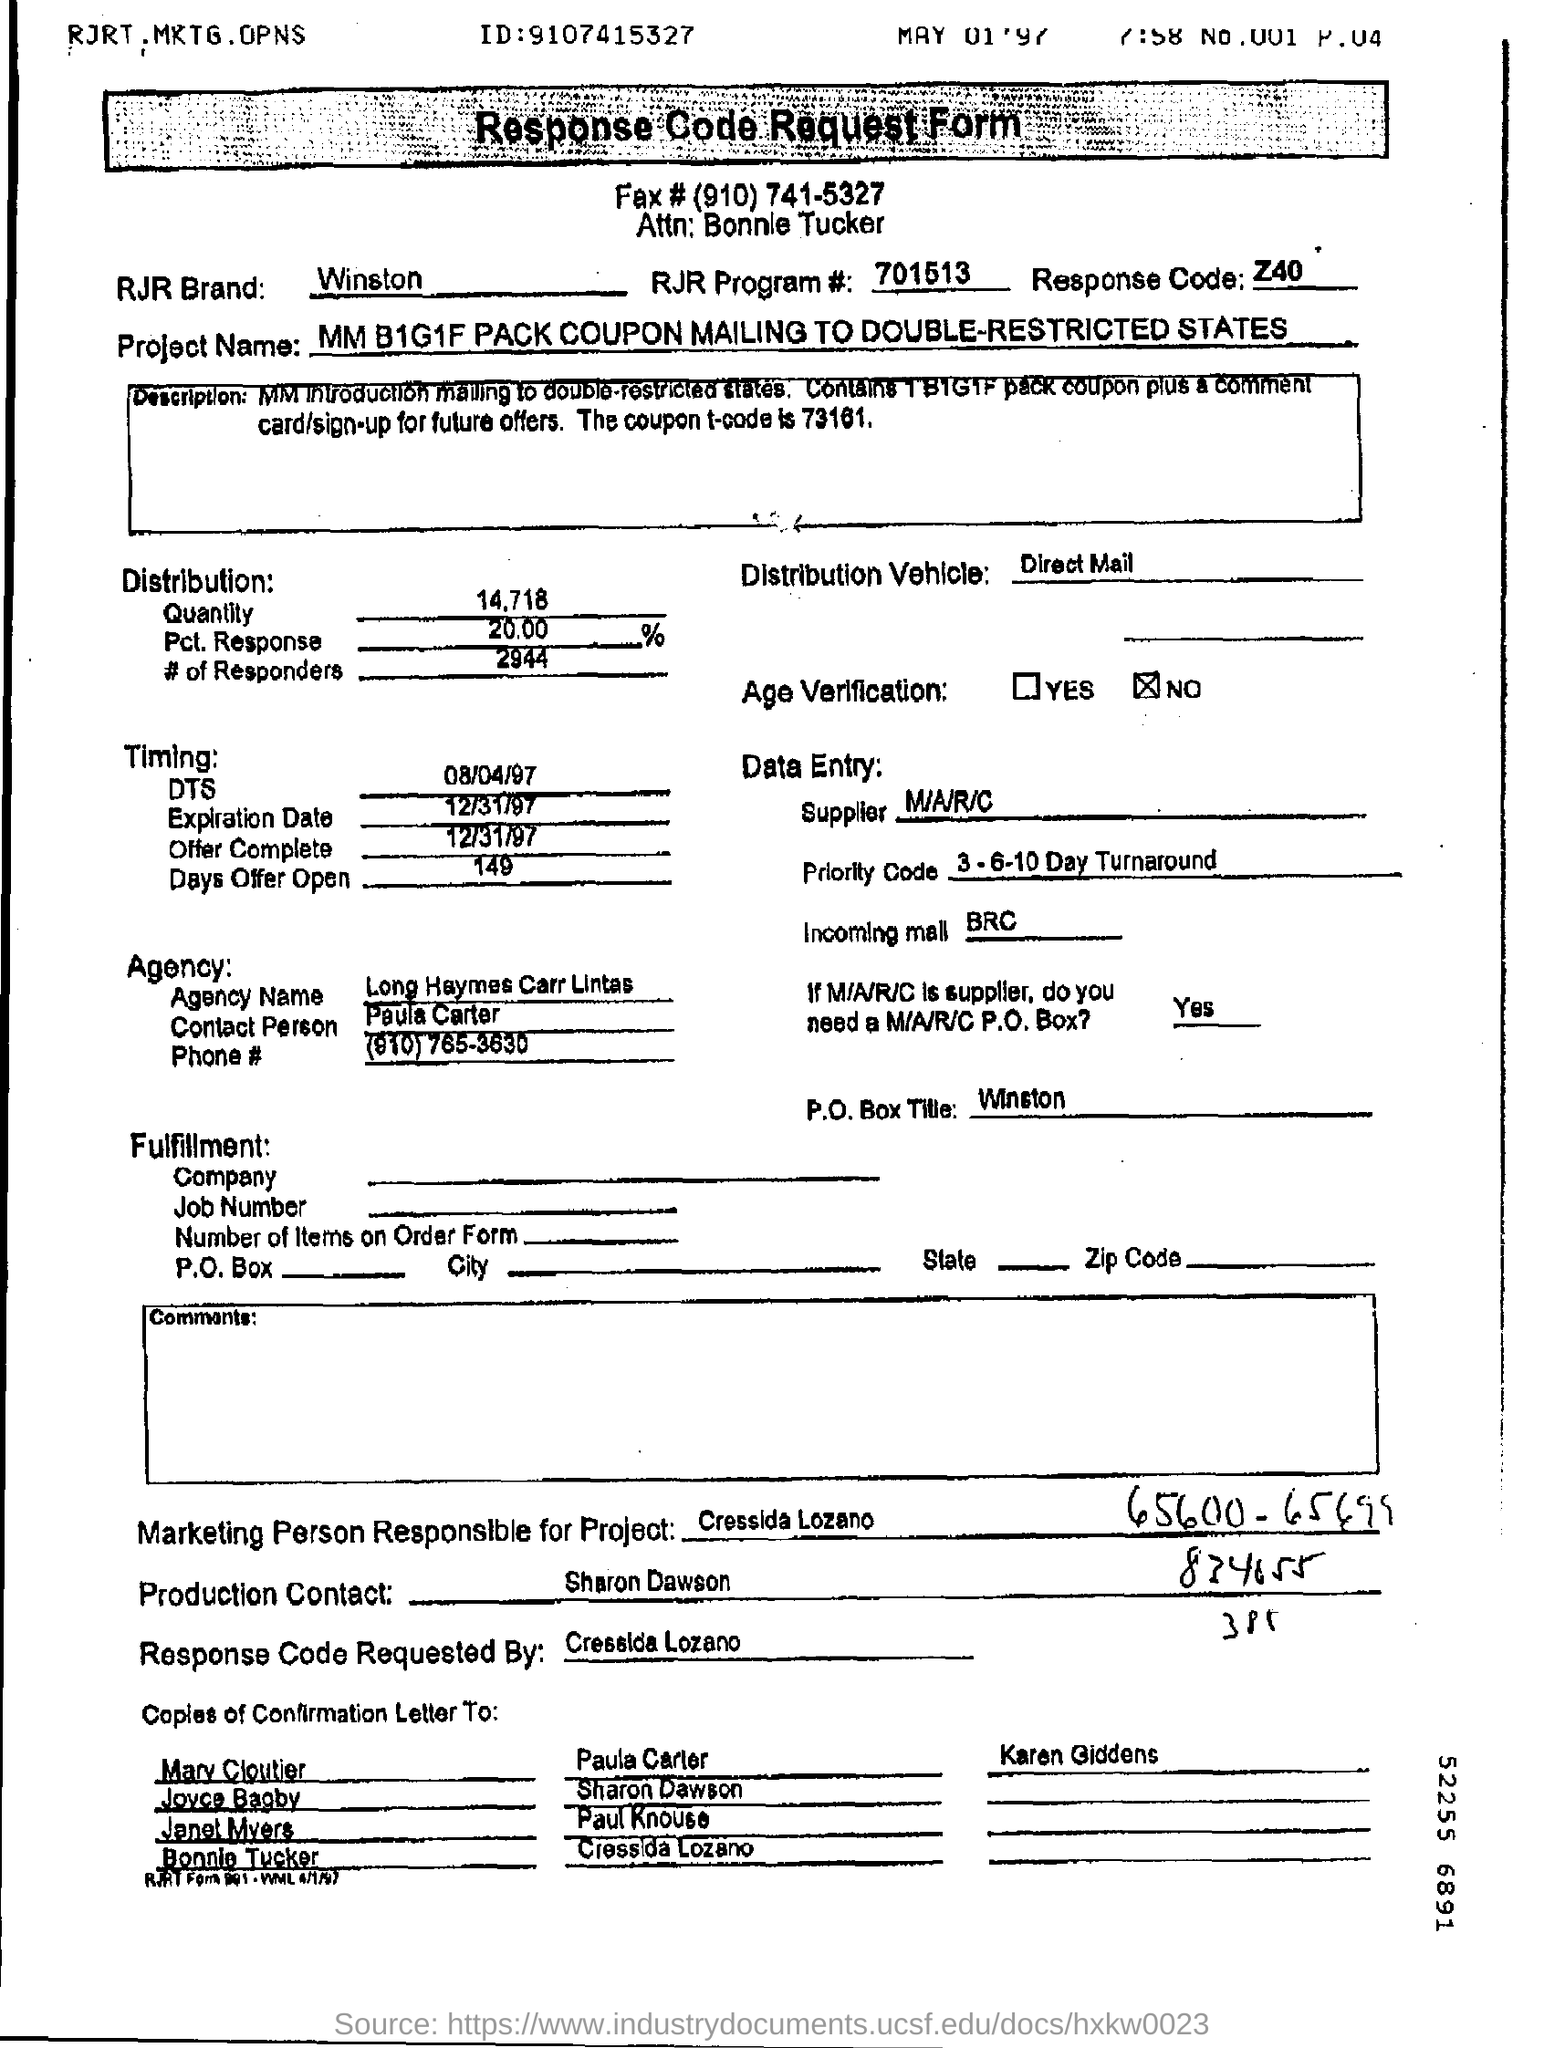Highlight a few significant elements in this photo. The RJR Brand is associated with the brand Winston, which is a cigarette brand known for its distinctive taste and quality. The project name is MM B1G1F PACK COUPON MAILING TO DOUBLE-RESTRICTED STATES. There are 2,944 responders in the distribution. The Production Contact is Sharon Dawson. 